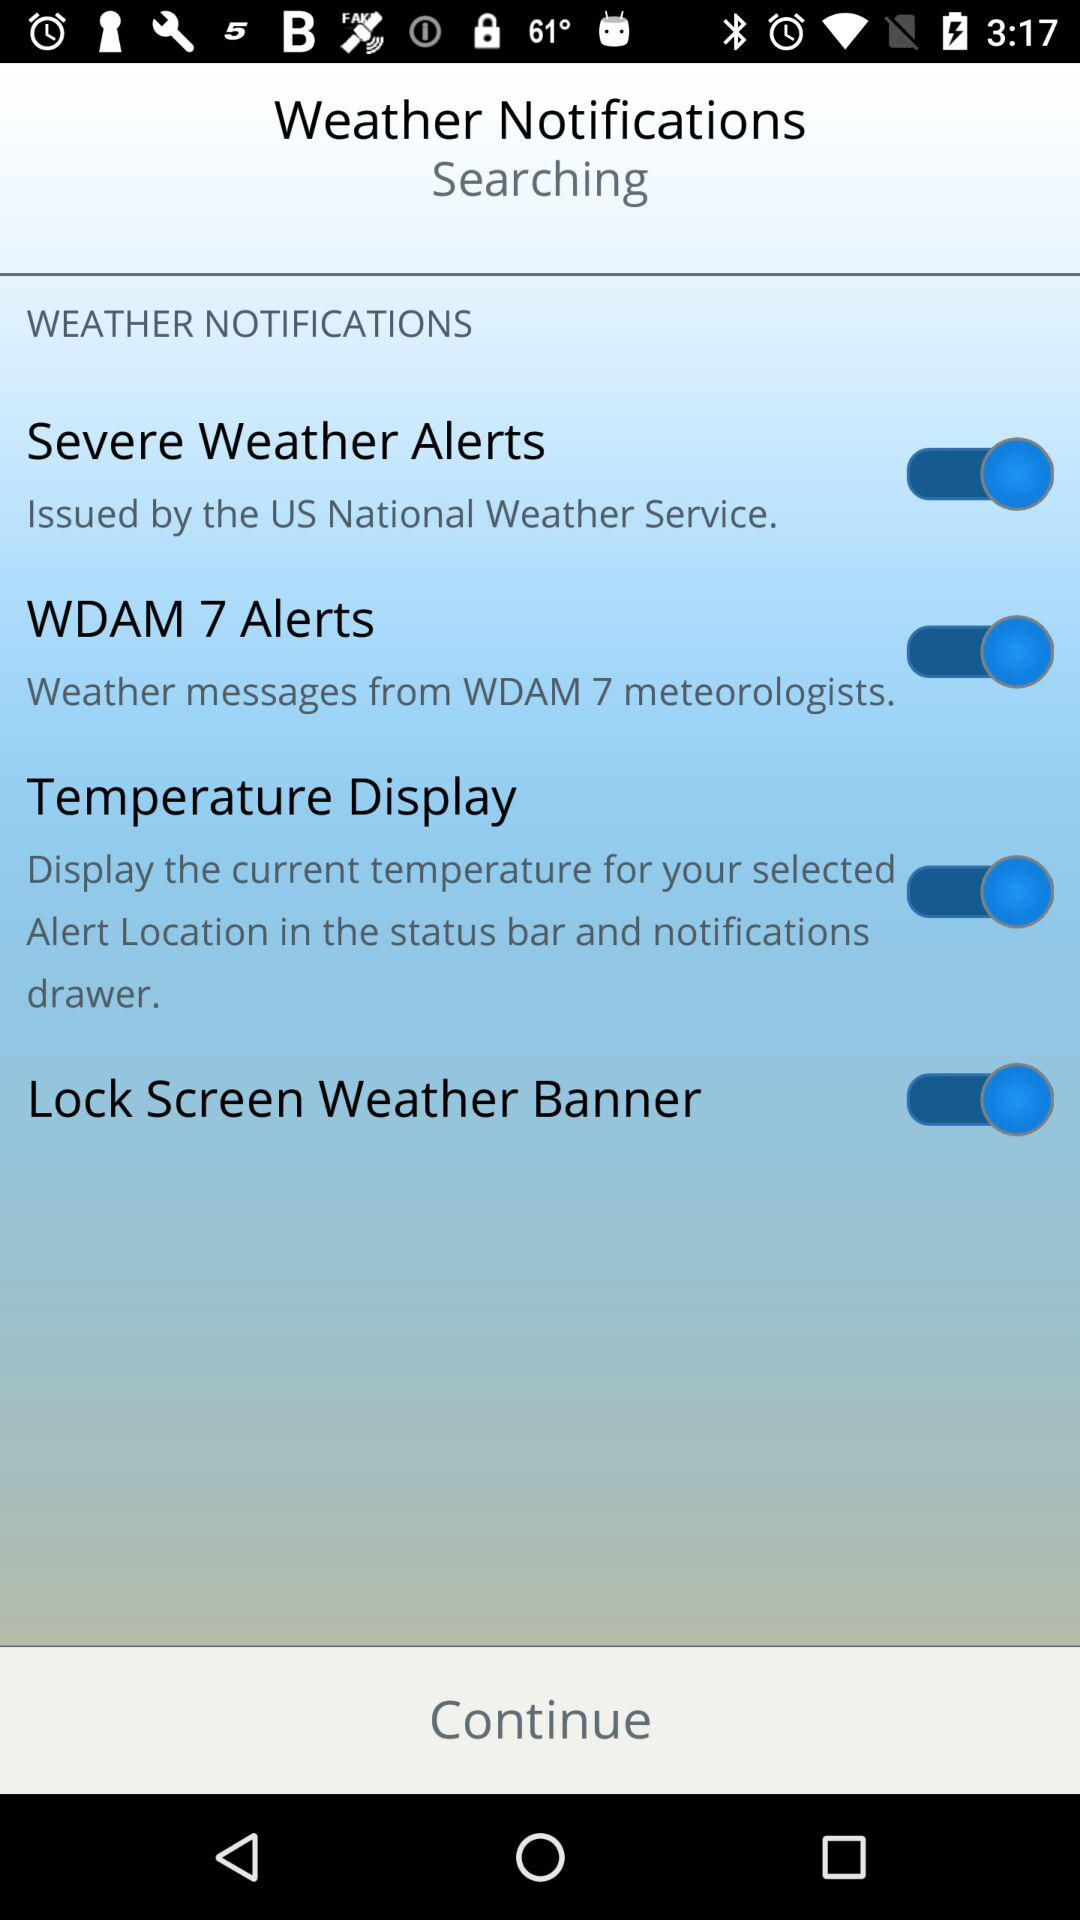What is the status of the "Temperature Display"? The status is "on". 